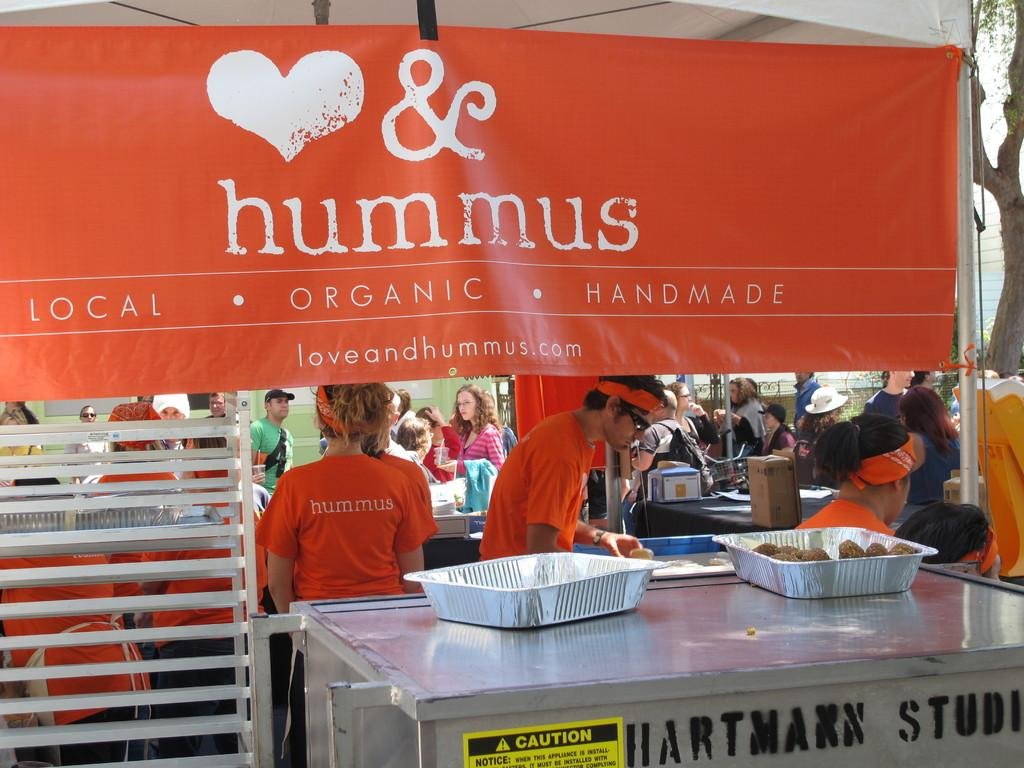What are the people in the image wearing? The people in the image are wearing clothes. What is located at the bottom of the image? There is a table at the bottom of the image. What is on the table? The table contains bowls. What is at the top of the image? There is a banner at the top of the image. What is written on the banner? The banner contains some text. What type of butter is being used to grease the fowl in the image? There is no butter or fowl present in the image. What is the base material of the table in the image? The base material of the table is not mentioned in the image, so it cannot be determined. 